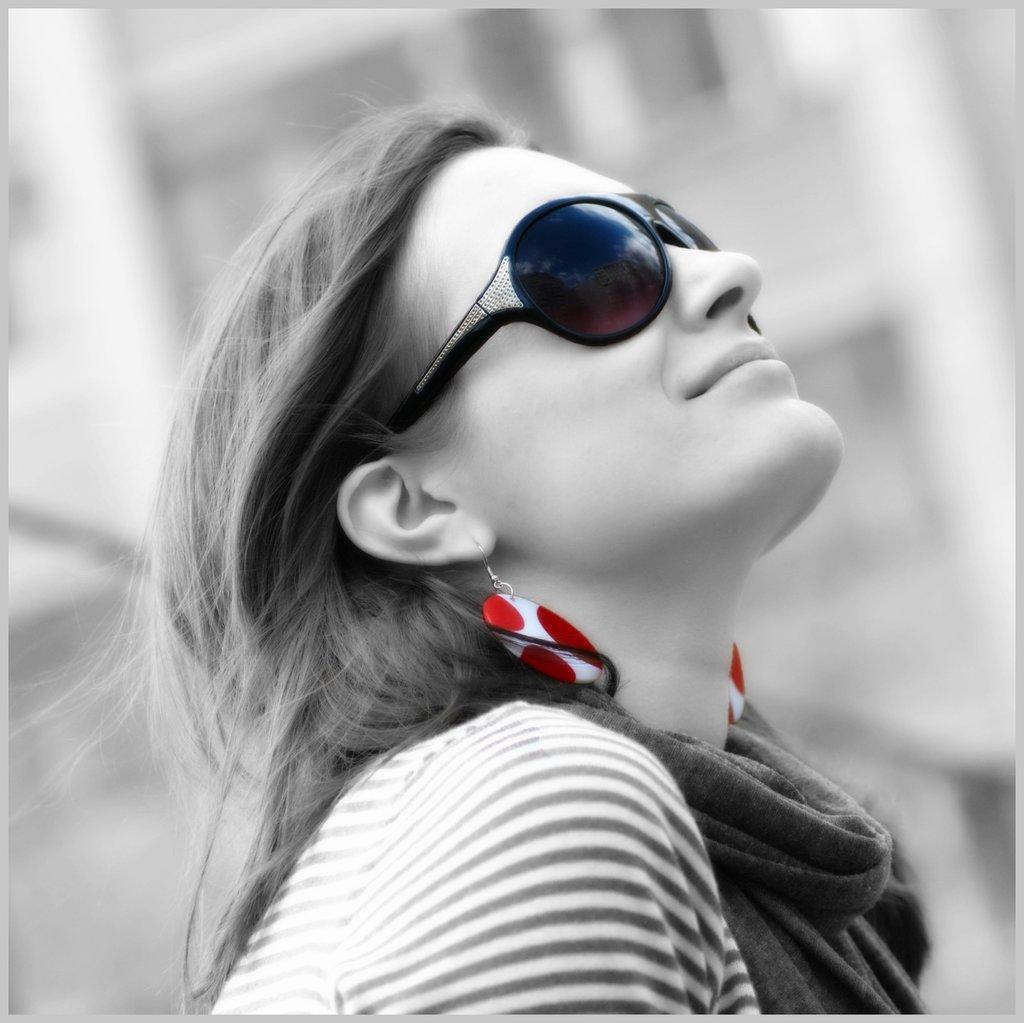Who is the main subject in the image? There is a lady in the center of the image. What is the lady wearing in the image? The lady is wearing sunglasses. What type of blade is being used by the lady in the image? There is no blade present in the image; the lady is wearing sunglasses. 